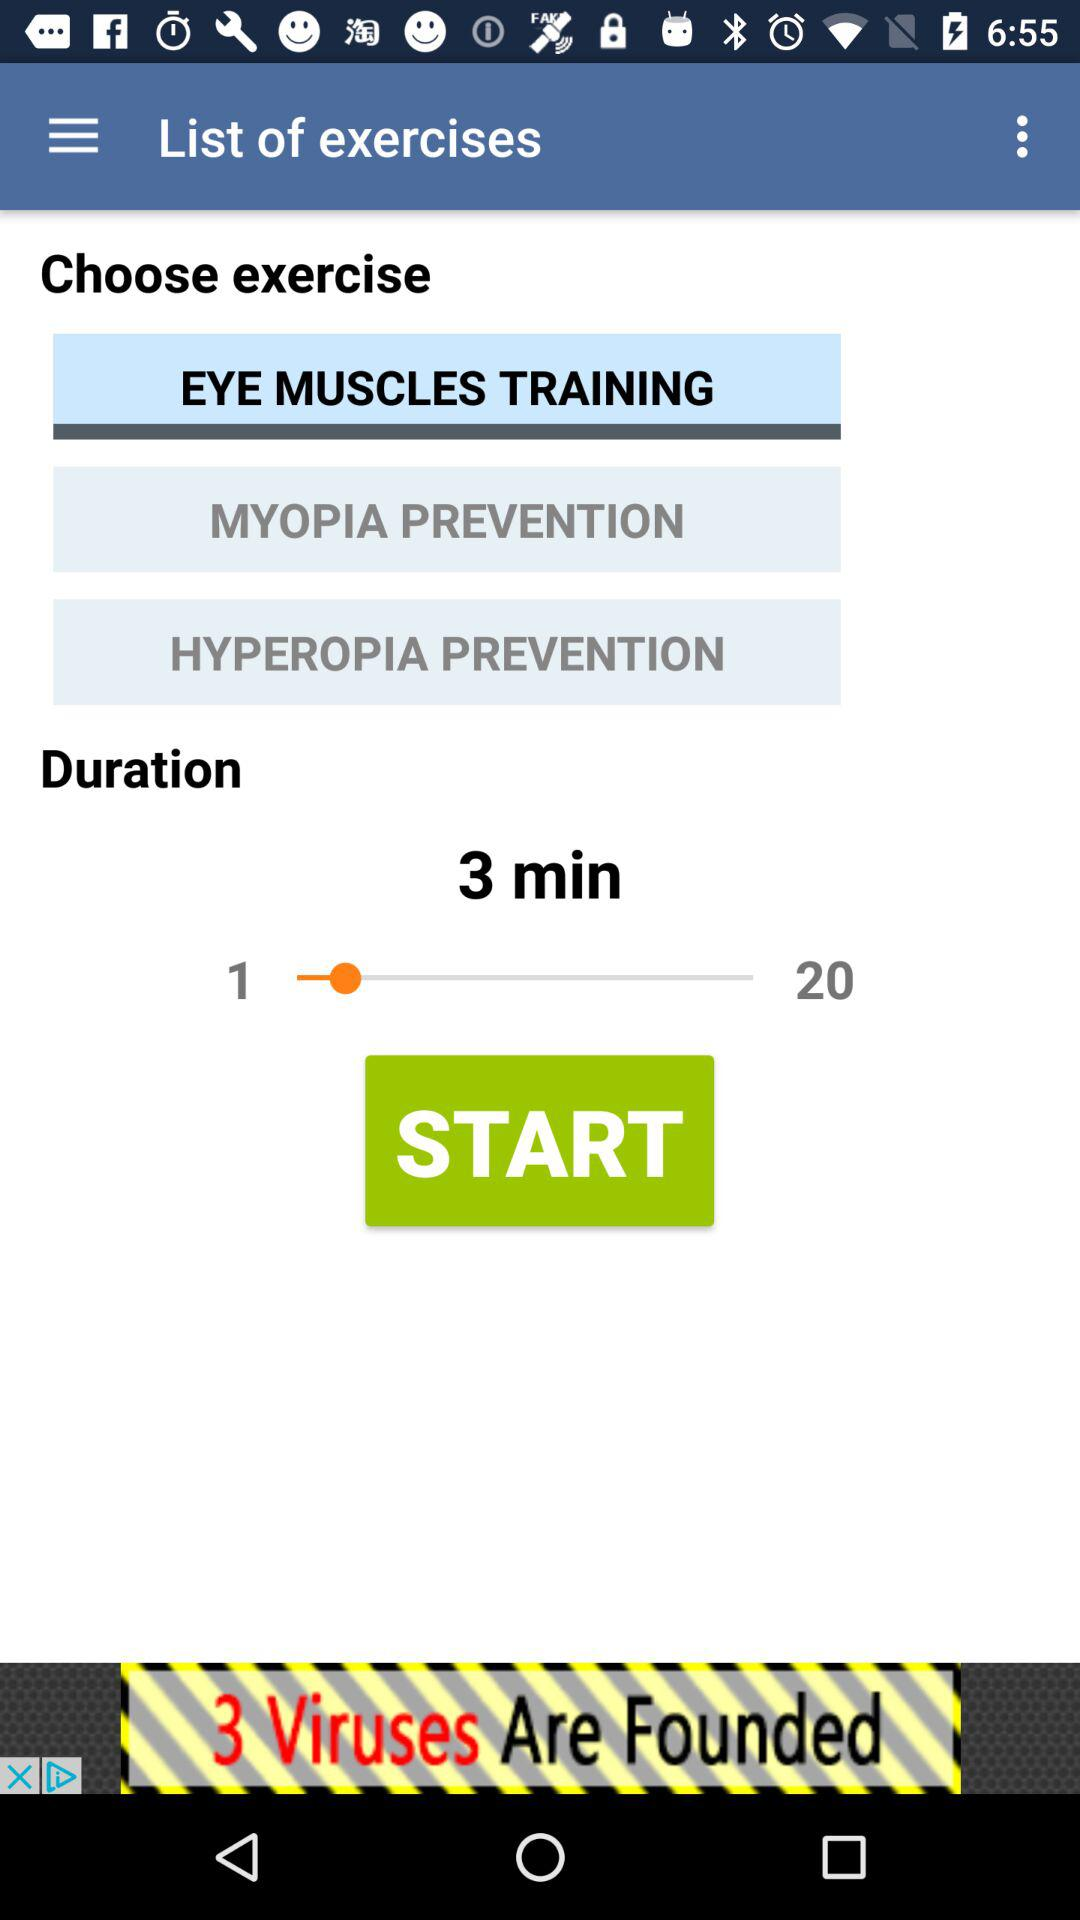What is the current time duration of the exercise? The current time duration of the exercise is 3 minutes. 